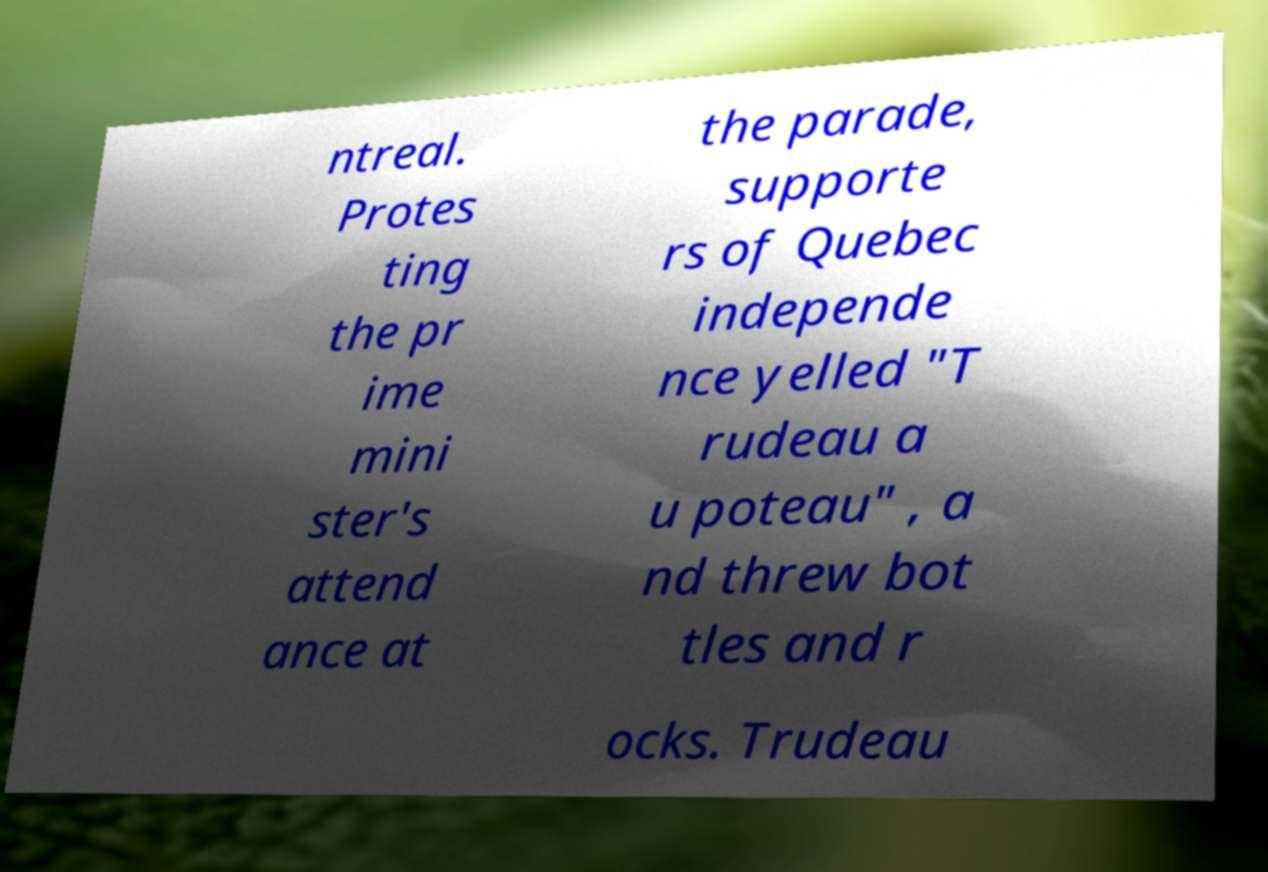There's text embedded in this image that I need extracted. Can you transcribe it verbatim? ntreal. Protes ting the pr ime mini ster's attend ance at the parade, supporte rs of Quebec independe nce yelled "T rudeau a u poteau" , a nd threw bot tles and r ocks. Trudeau 